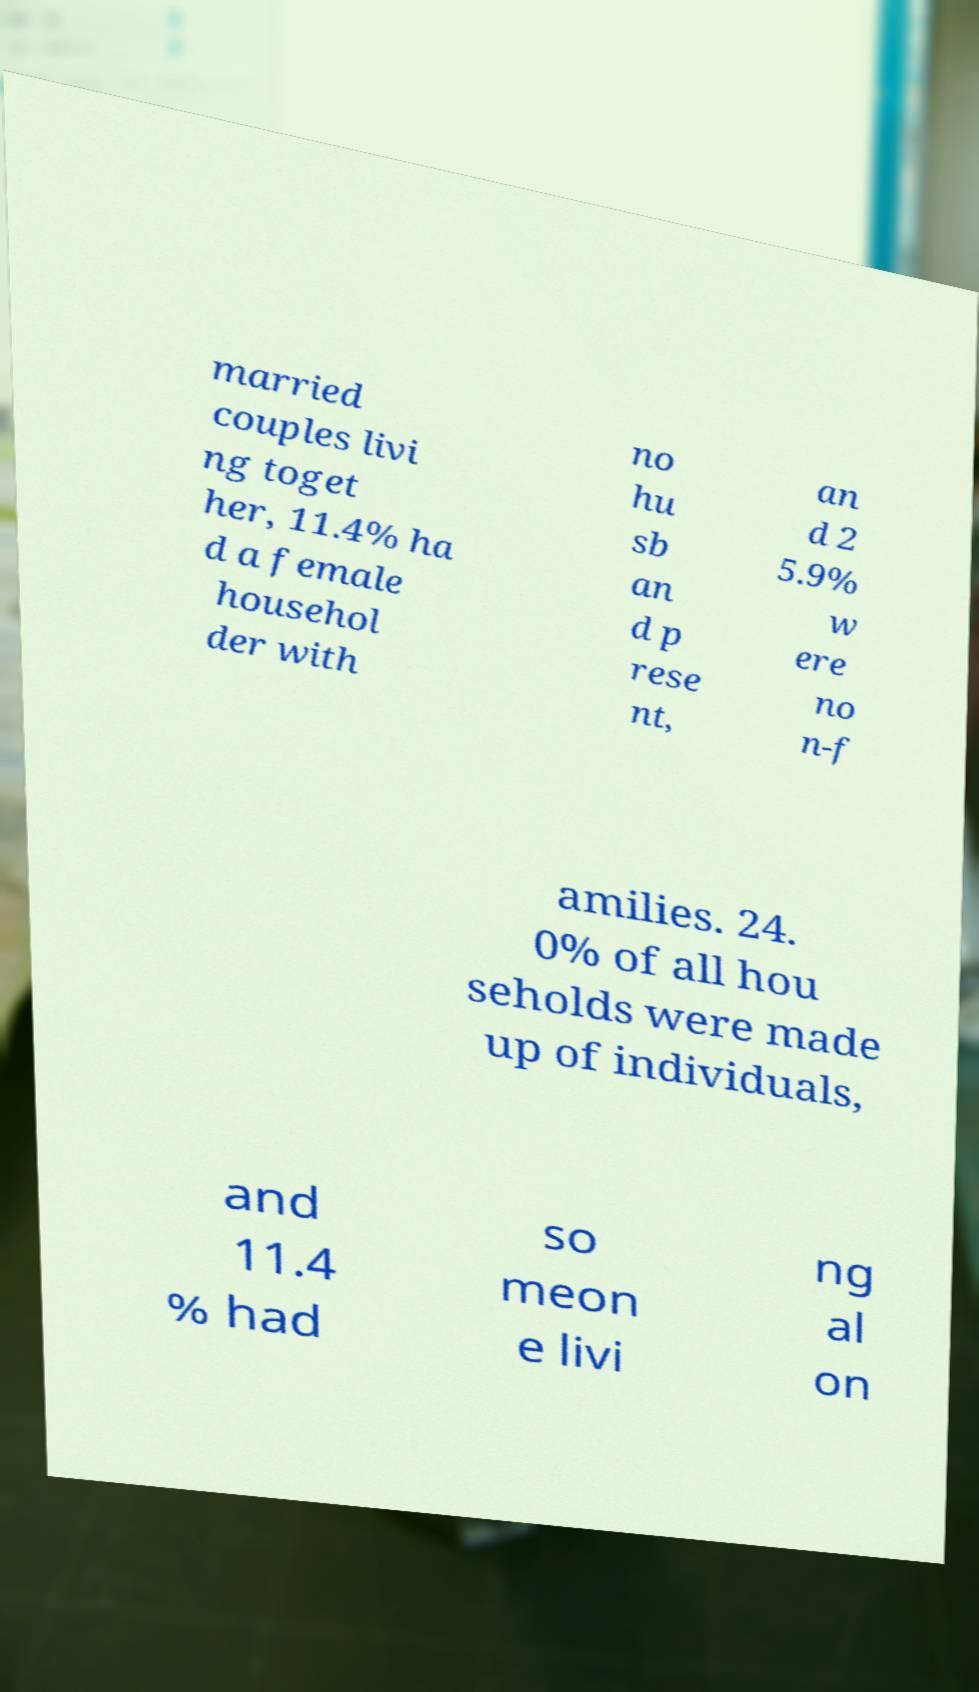Please identify and transcribe the text found in this image. married couples livi ng toget her, 11.4% ha d a female househol der with no hu sb an d p rese nt, an d 2 5.9% w ere no n-f amilies. 24. 0% of all hou seholds were made up of individuals, and 11.4 % had so meon e livi ng al on 